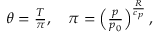Convert formula to latex. <formula><loc_0><loc_0><loc_500><loc_500>\begin{array} { r } { \theta = \frac { T } { \pi } , \quad \pi = \left ( \frac { p } { p _ { 0 } } \right ) ^ { \frac { R } { c _ { p } } } , } \end{array}</formula> 